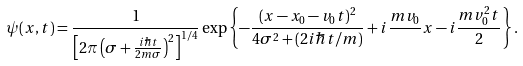Convert formula to latex. <formula><loc_0><loc_0><loc_500><loc_500>\psi ( x , t ) = \frac { 1 } { \left [ 2 \pi \left ( \sigma + \frac { i \hbar { t } } { 2 m \sigma } \right ) ^ { 2 } \right ] ^ { 1 / 4 } } \exp \left \{ - \frac { ( x - x _ { 0 } - v _ { 0 } t ) ^ { 2 } } { 4 \sigma ^ { 2 } + ( 2 i \hbar { t } / m ) } + i \frac { m v _ { 0 } } { } x - i \frac { m v ^ { 2 } _ { 0 } t } { 2 } \right \} .</formula> 